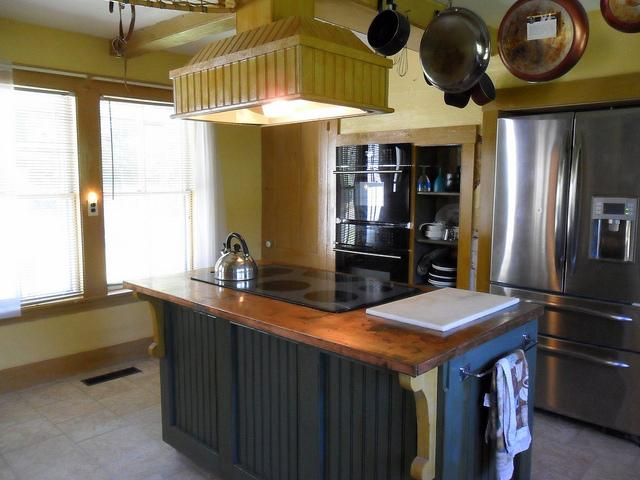What is the white rectangle on the island for?

Choices:
A) cutting
B) decoration
C) mixing
D) warming cutting 